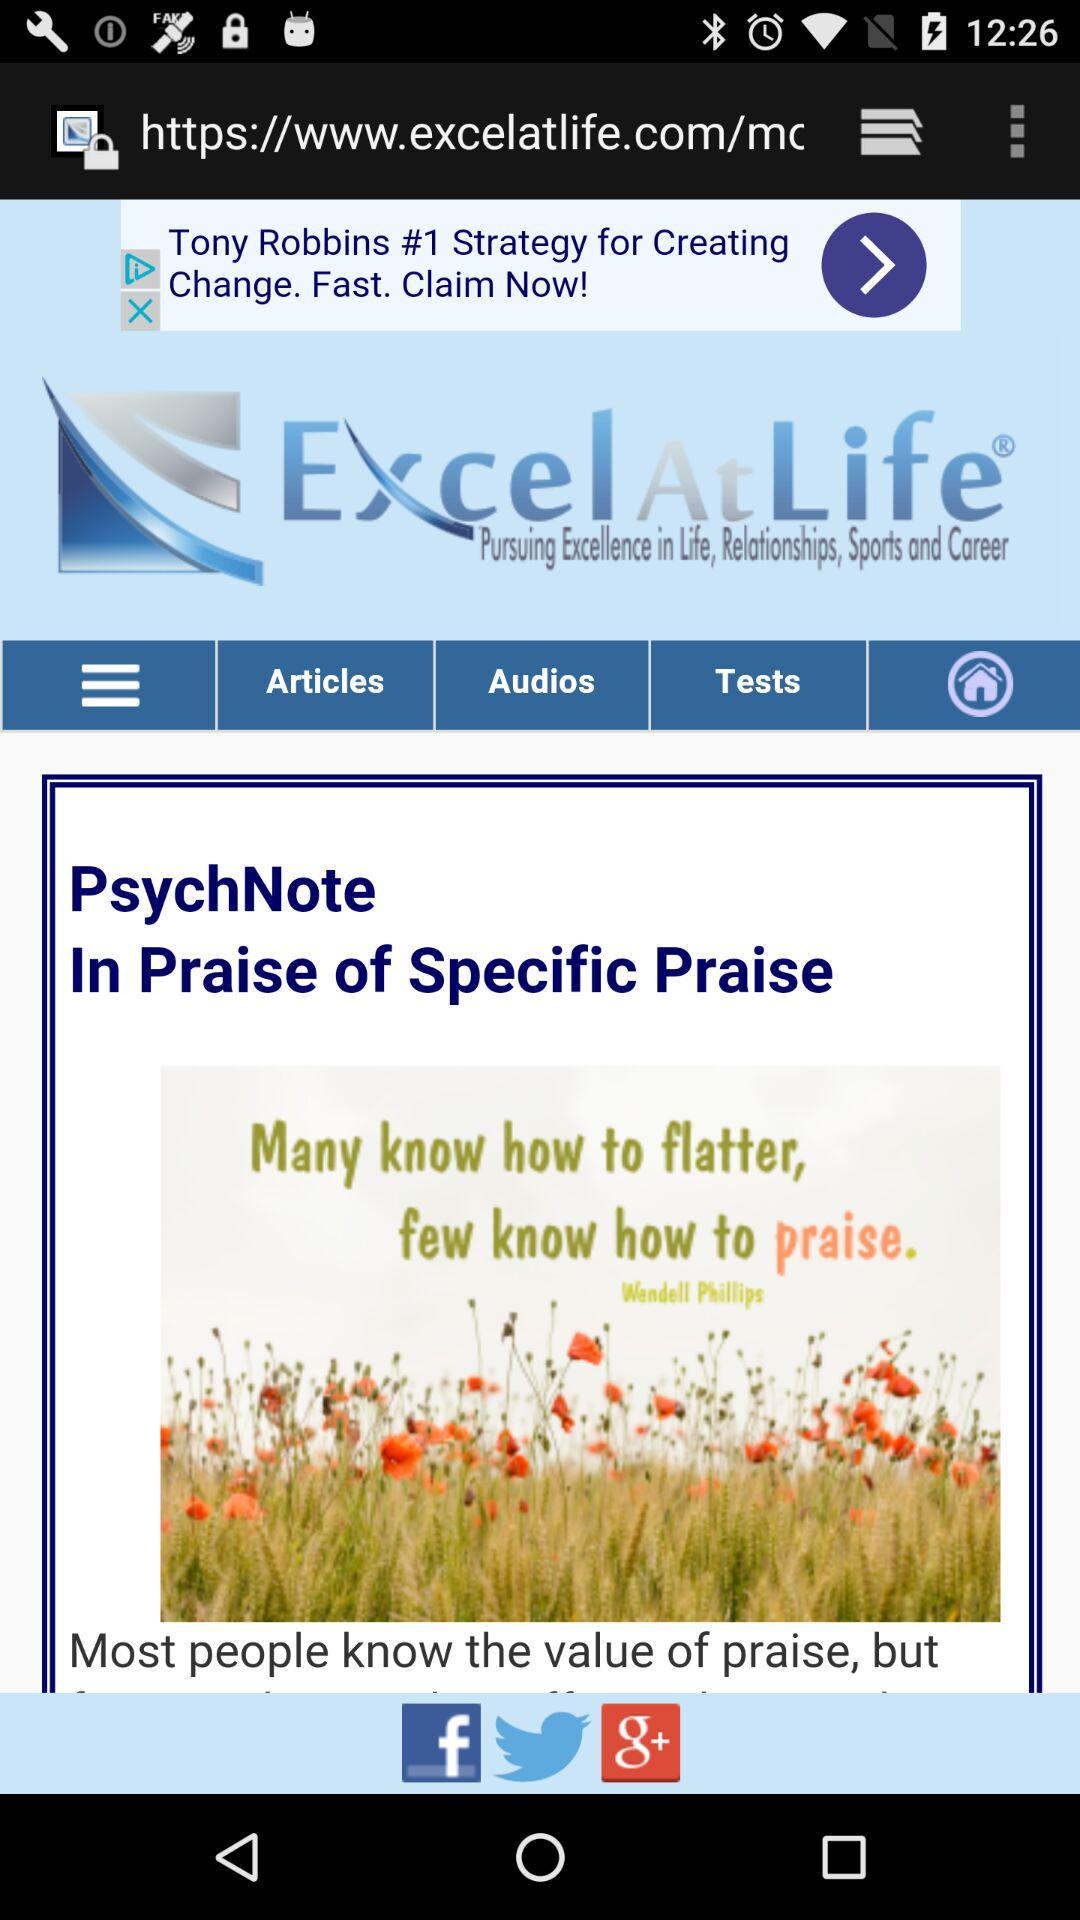What is the name of the application? The name of the application is "Excel At Life". 